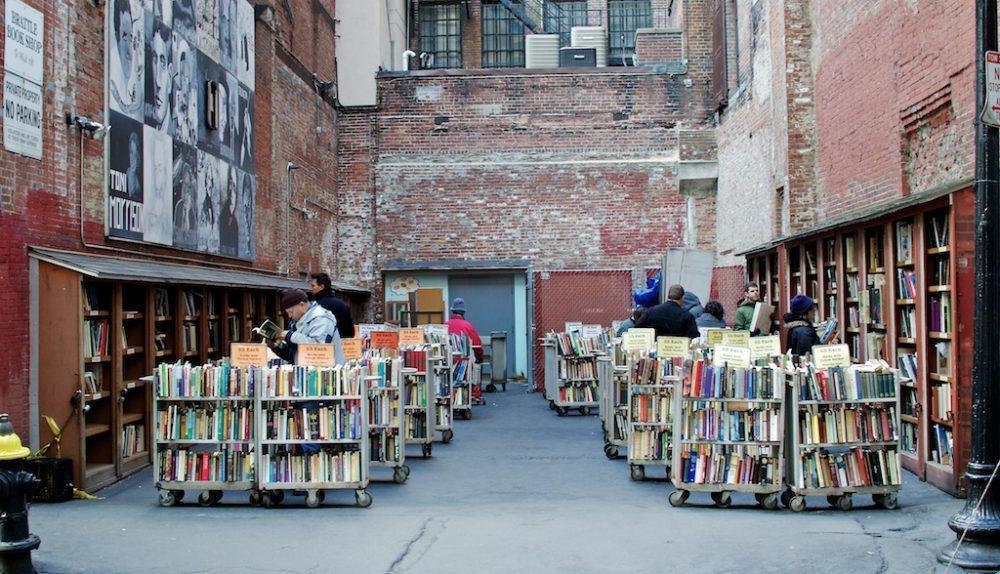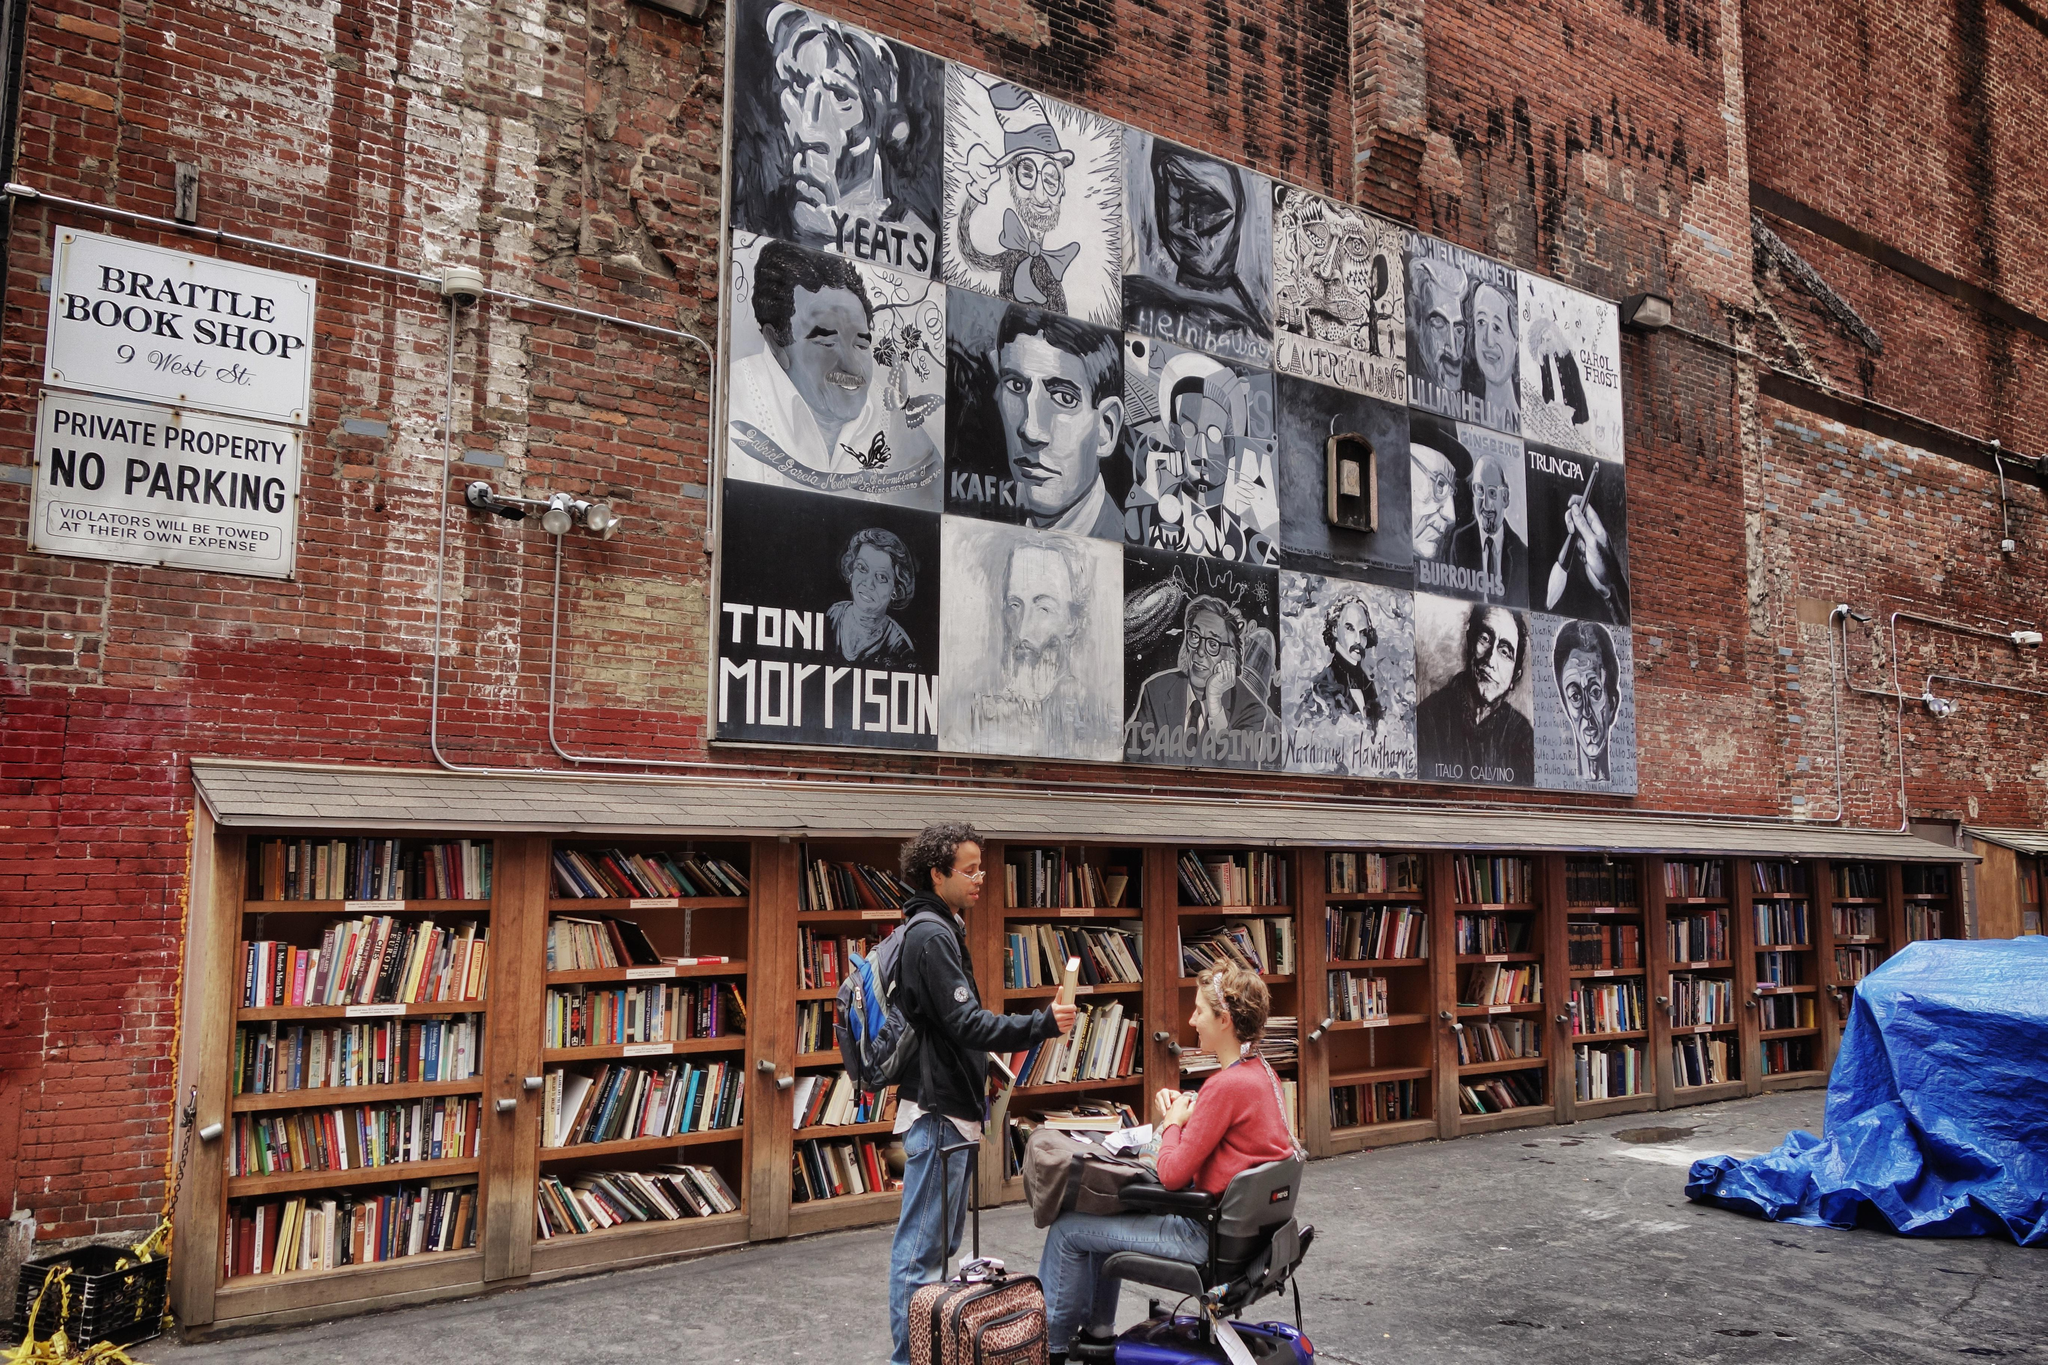The first image is the image on the left, the second image is the image on the right. Assess this claim about the two images: "stairs can be seen in the image on the left". Correct or not? Answer yes or no. No. The first image is the image on the left, the second image is the image on the right. Examine the images to the left and right. Is the description "A light sits on a pole on the street." accurate? Answer yes or no. No. 